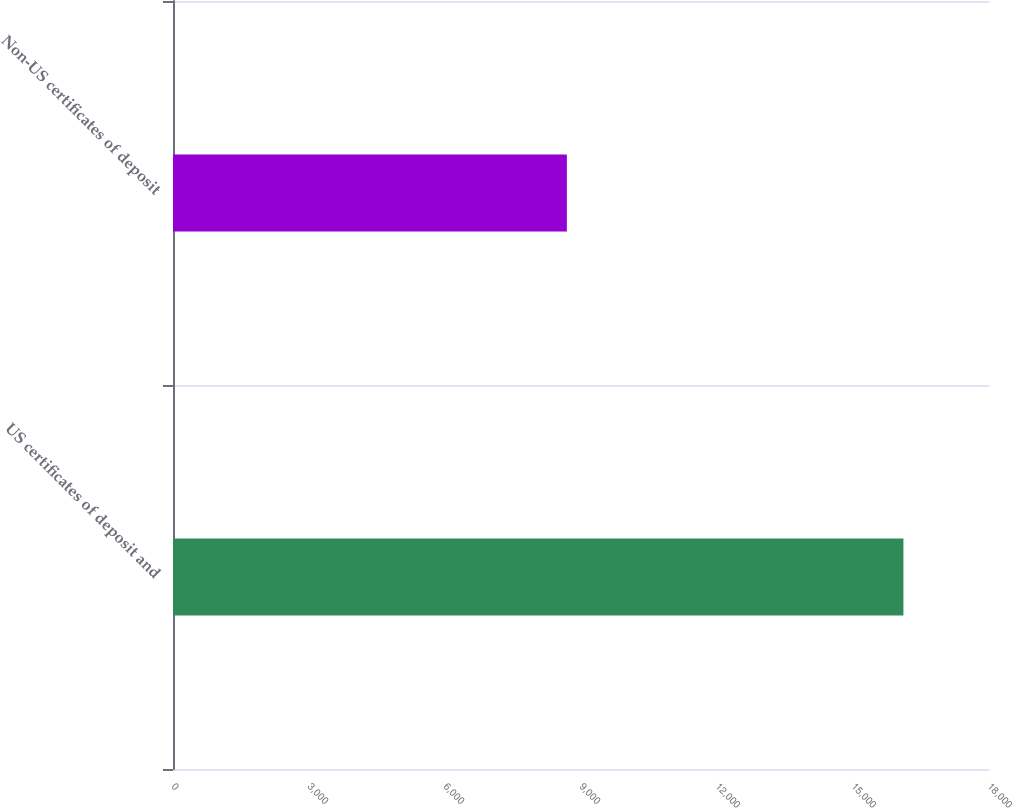Convert chart. <chart><loc_0><loc_0><loc_500><loc_500><bar_chart><fcel>US certificates of deposit and<fcel>Non-US certificates of deposit<nl><fcel>16112<fcel>8688<nl></chart> 